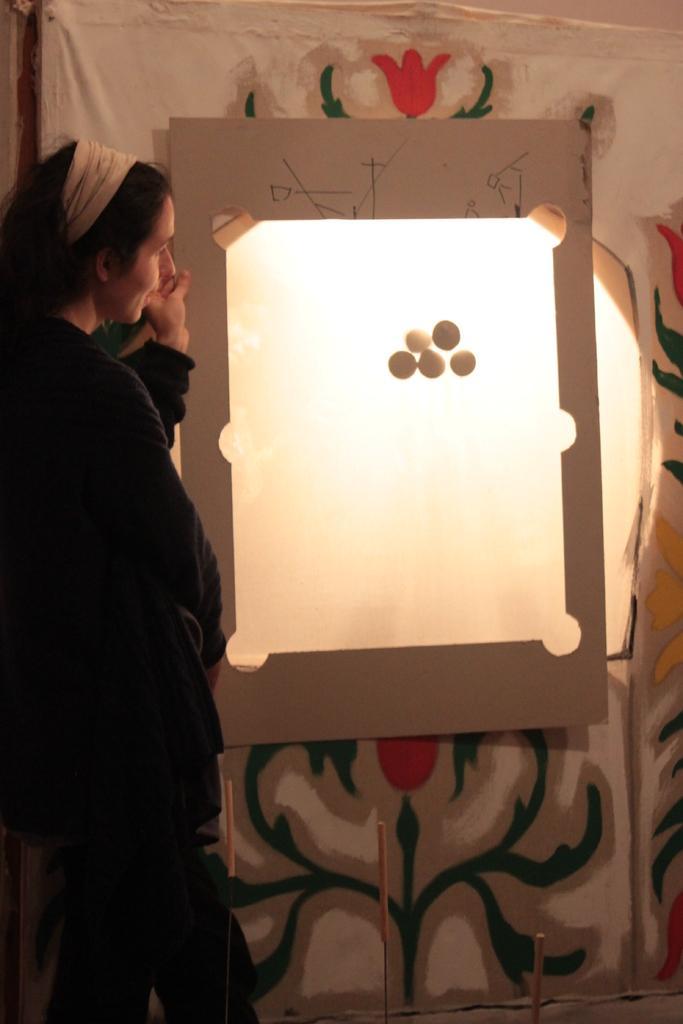In one or two sentences, can you explain what this image depicts? In this image I can see a woman is standing. Here I can see a board and some other objects. 